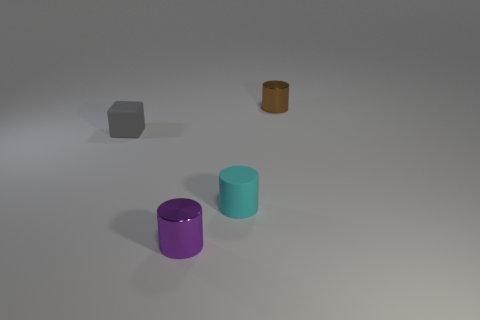Can you speculate on what these objects could be used for? Certainly! The cylinders might be containers or parts of a modular storage system, while the cube could serve as a paperweight, a decorative element, or a children's block. The small brown cylinder could be part of a game or a crafting material. 